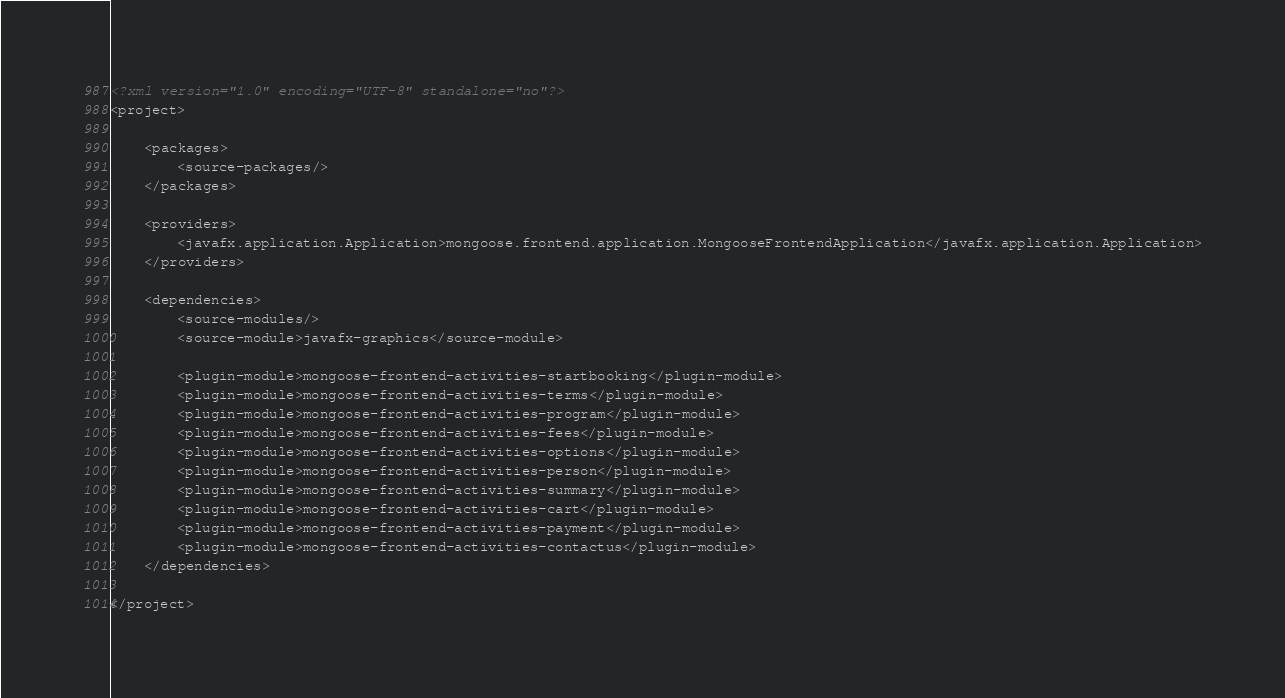Convert code to text. <code><loc_0><loc_0><loc_500><loc_500><_XML_><?xml version="1.0" encoding="UTF-8" standalone="no"?>
<project>

    <packages>
        <source-packages/>
    </packages>

    <providers>
        <javafx.application.Application>mongoose.frontend.application.MongooseFrontendApplication</javafx.application.Application>
    </providers>

    <dependencies>
        <source-modules/>
        <source-module>javafx-graphics</source-module>

        <plugin-module>mongoose-frontend-activities-startbooking</plugin-module>
        <plugin-module>mongoose-frontend-activities-terms</plugin-module>
        <plugin-module>mongoose-frontend-activities-program</plugin-module>
        <plugin-module>mongoose-frontend-activities-fees</plugin-module>
        <plugin-module>mongoose-frontend-activities-options</plugin-module>
        <plugin-module>mongoose-frontend-activities-person</plugin-module>
        <plugin-module>mongoose-frontend-activities-summary</plugin-module>
        <plugin-module>mongoose-frontend-activities-cart</plugin-module>
        <plugin-module>mongoose-frontend-activities-payment</plugin-module>
        <plugin-module>mongoose-frontend-activities-contactus</plugin-module>
    </dependencies>

</project></code> 